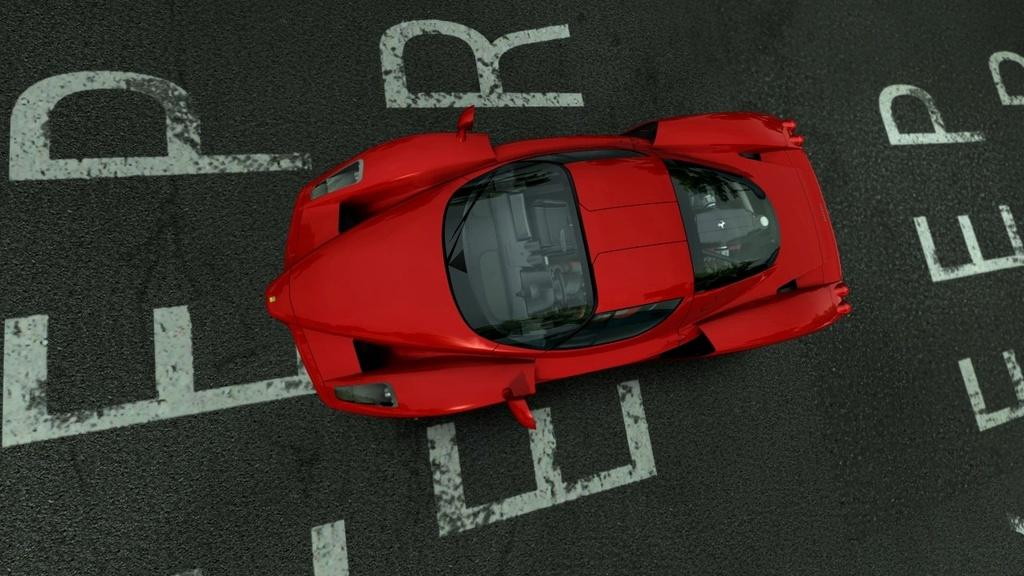What is the main subject in the foreground of the image? There is a red color car in the foreground of the image. Where is the car located? The car is on the road. What additional detail can be observed on the car? There is text written on the car. Can you see a rose on the car in the image? There is no rose present on the car in the image. 